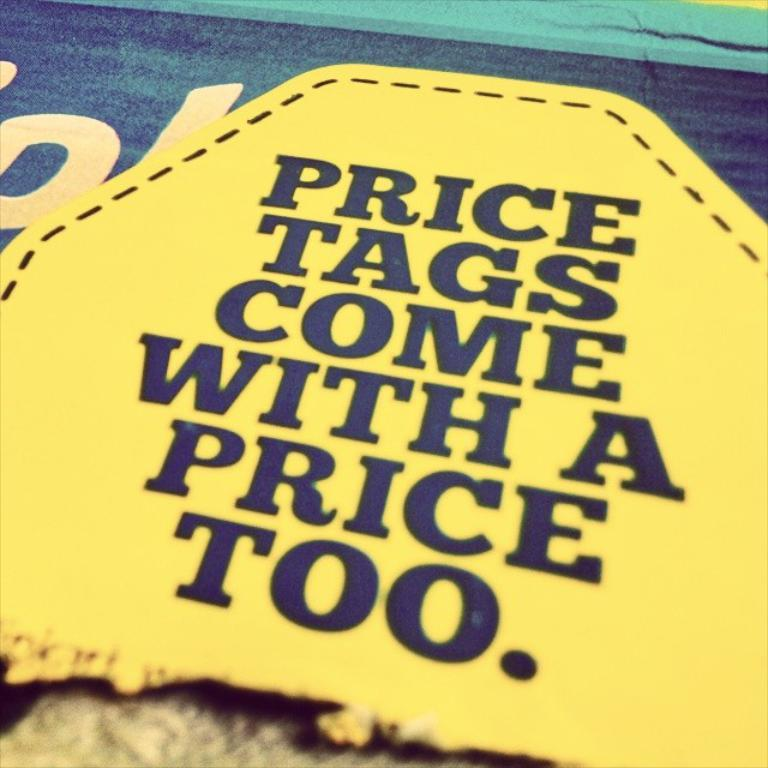<image>
Create a compact narrative representing the image presented. A message states that price tags come with a price too. 